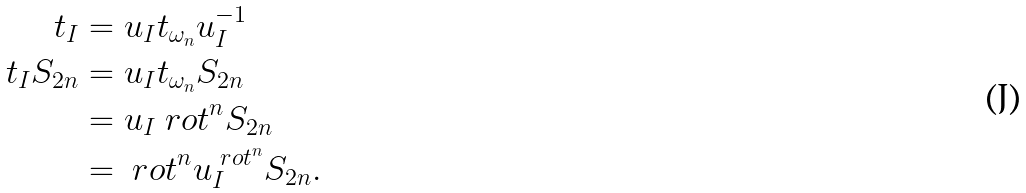Convert formula to latex. <formula><loc_0><loc_0><loc_500><loc_500>t _ { I } & = u _ { I } t _ { \omega _ { n } } u _ { I } ^ { - 1 } \\ t _ { I } S _ { 2 n } & = u _ { I } t _ { \omega _ { n } } S _ { 2 n } \\ & = u _ { I } \ r o t ^ { n } S _ { 2 n } \\ & = \ r o t ^ { n } u _ { I } ^ { \ r o t ^ { n } } S _ { 2 n } .</formula> 